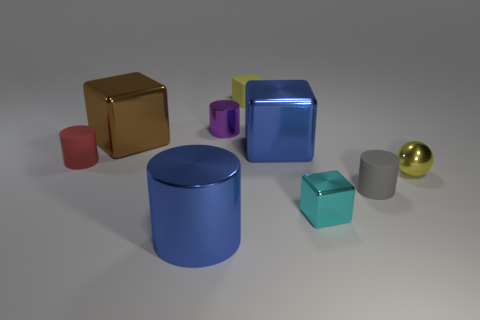Is there anything else that is the same shape as the small yellow shiny thing?
Provide a succinct answer. No. There is a yellow thing that is right of the rubber object on the right side of the blue shiny object that is behind the big blue cylinder; how big is it?
Offer a very short reply. Small. What number of other objects are the same size as the yellow shiny object?
Make the answer very short. 5. There is a shiny object that is to the right of the cyan cube; what is its size?
Offer a very short reply. Small. Is there any other thing that is the same color as the shiny ball?
Offer a very short reply. Yes. Are the cylinder right of the tiny cyan shiny block and the cyan object made of the same material?
Your response must be concise. No. How many small cylinders are both on the right side of the large metallic cylinder and behind the small shiny ball?
Offer a terse response. 1. What is the size of the matte cylinder that is to the right of the blue metal thing in front of the tiny ball?
Keep it short and to the point. Small. Are there more large green rubber spheres than brown blocks?
Your answer should be very brief. No. Do the tiny matte object that is in front of the small red object and the tiny object that is behind the tiny metal cylinder have the same color?
Your answer should be compact. No. 